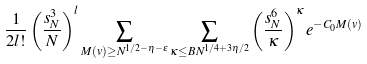<formula> <loc_0><loc_0><loc_500><loc_500>\frac { 1 } { 2 l ! } \left ( \frac { s _ { N } ^ { 3 } } { N } \right ) ^ { l } \sum _ { M ( v ) \geq N ^ { 1 / 2 - \eta - \epsilon } } \sum _ { \kappa \leq B N ^ { 1 / 4 + 3 \eta / 2 } } \left ( \frac { s _ { N } ^ { 6 } } { \kappa } \right ) ^ { \kappa } e ^ { - C _ { 0 } M ( v ) }</formula> 